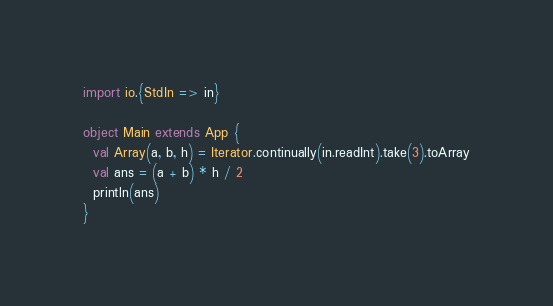<code> <loc_0><loc_0><loc_500><loc_500><_Scala_>import io.{StdIn => in}

object Main extends App {
  val Array(a, b, h) = Iterator.continually(in.readInt).take(3).toArray
  val ans = (a + b) * h / 2
  println(ans)
}</code> 